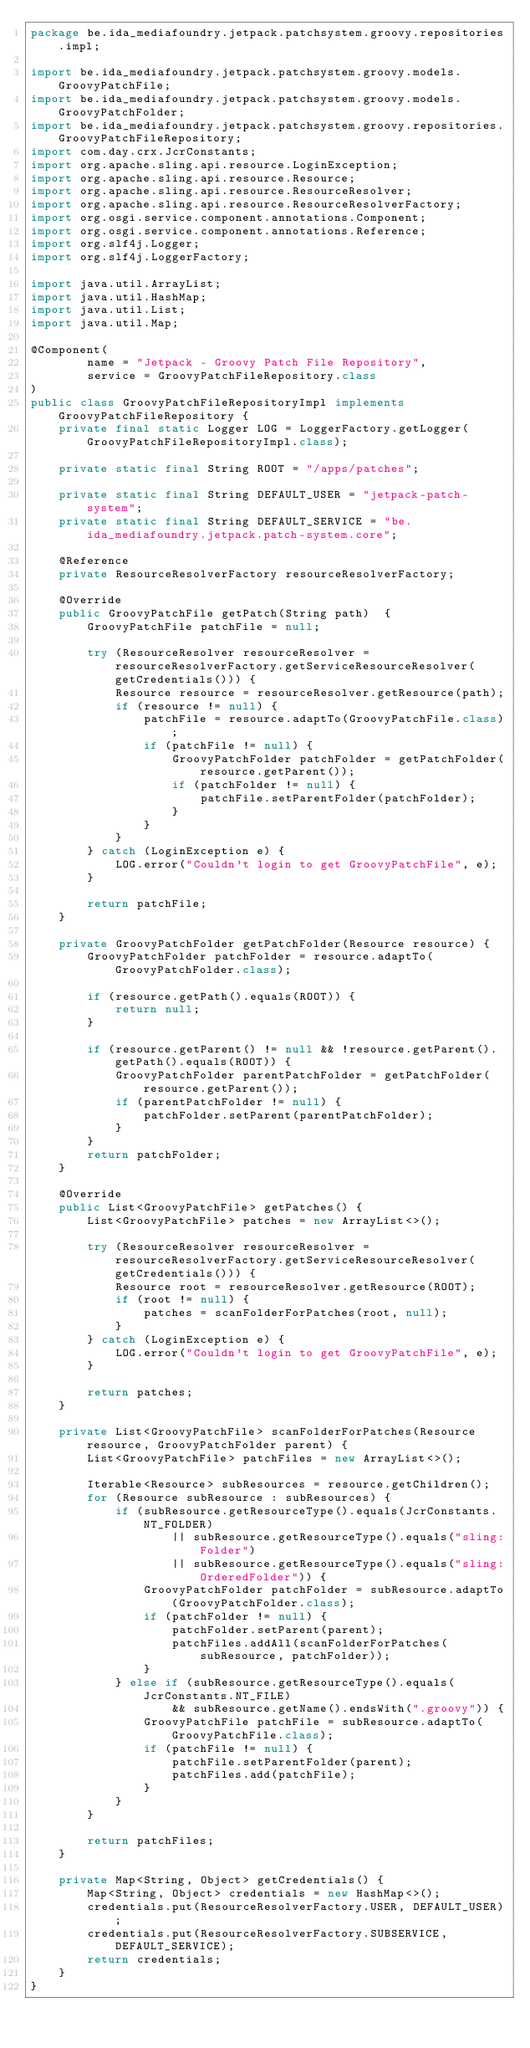Convert code to text. <code><loc_0><loc_0><loc_500><loc_500><_Java_>package be.ida_mediafoundry.jetpack.patchsystem.groovy.repositories.impl;

import be.ida_mediafoundry.jetpack.patchsystem.groovy.models.GroovyPatchFile;
import be.ida_mediafoundry.jetpack.patchsystem.groovy.models.GroovyPatchFolder;
import be.ida_mediafoundry.jetpack.patchsystem.groovy.repositories.GroovyPatchFileRepository;
import com.day.crx.JcrConstants;
import org.apache.sling.api.resource.LoginException;
import org.apache.sling.api.resource.Resource;
import org.apache.sling.api.resource.ResourceResolver;
import org.apache.sling.api.resource.ResourceResolverFactory;
import org.osgi.service.component.annotations.Component;
import org.osgi.service.component.annotations.Reference;
import org.slf4j.Logger;
import org.slf4j.LoggerFactory;

import java.util.ArrayList;
import java.util.HashMap;
import java.util.List;
import java.util.Map;

@Component(
        name = "Jetpack - Groovy Patch File Repository",
        service = GroovyPatchFileRepository.class
)
public class GroovyPatchFileRepositoryImpl implements GroovyPatchFileRepository {
    private final static Logger LOG = LoggerFactory.getLogger(GroovyPatchFileRepositoryImpl.class);

    private static final String ROOT = "/apps/patches";

    private static final String DEFAULT_USER = "jetpack-patch-system";
    private static final String DEFAULT_SERVICE = "be.ida_mediafoundry.jetpack.patch-system.core";

    @Reference
    private ResourceResolverFactory resourceResolverFactory;

    @Override
    public GroovyPatchFile getPatch(String path)  {
        GroovyPatchFile patchFile = null;

        try (ResourceResolver resourceResolver = resourceResolverFactory.getServiceResourceResolver(getCredentials())) {
            Resource resource = resourceResolver.getResource(path);
            if (resource != null) {
                patchFile = resource.adaptTo(GroovyPatchFile.class);
                if (patchFile != null) {
                    GroovyPatchFolder patchFolder = getPatchFolder(resource.getParent());
                    if (patchFolder != null) {
                        patchFile.setParentFolder(patchFolder);
                    }
                }
            }
        } catch (LoginException e) {
            LOG.error("Couldn't login to get GroovyPatchFile", e);
        }

        return patchFile;
    }

    private GroovyPatchFolder getPatchFolder(Resource resource) {
        GroovyPatchFolder patchFolder = resource.adaptTo(GroovyPatchFolder.class);

        if (resource.getPath().equals(ROOT)) {
            return null;
        }

        if (resource.getParent() != null && !resource.getParent().getPath().equals(ROOT)) {
            GroovyPatchFolder parentPatchFolder = getPatchFolder(resource.getParent());
            if (parentPatchFolder != null) {
                patchFolder.setParent(parentPatchFolder);
            }
        }
        return patchFolder;
    }

    @Override
    public List<GroovyPatchFile> getPatches() {
        List<GroovyPatchFile> patches = new ArrayList<>();

        try (ResourceResolver resourceResolver = resourceResolverFactory.getServiceResourceResolver(getCredentials())) {
            Resource root = resourceResolver.getResource(ROOT);
            if (root != null) {
                patches = scanFolderForPatches(root, null);
            }
        } catch (LoginException e) {
            LOG.error("Couldn't login to get GroovyPatchFile", e);
        }

        return patches;
    }

    private List<GroovyPatchFile> scanFolderForPatches(Resource resource, GroovyPatchFolder parent) {
        List<GroovyPatchFile> patchFiles = new ArrayList<>();

        Iterable<Resource> subResources = resource.getChildren();
        for (Resource subResource : subResources) {
            if (subResource.getResourceType().equals(JcrConstants.NT_FOLDER)
                    || subResource.getResourceType().equals("sling:Folder")
                    || subResource.getResourceType().equals("sling:OrderedFolder")) {
                GroovyPatchFolder patchFolder = subResource.adaptTo(GroovyPatchFolder.class);
                if (patchFolder != null) {
                    patchFolder.setParent(parent);
                    patchFiles.addAll(scanFolderForPatches(subResource, patchFolder));
                }
            } else if (subResource.getResourceType().equals(JcrConstants.NT_FILE)
                    && subResource.getName().endsWith(".groovy")) {
                GroovyPatchFile patchFile = subResource.adaptTo(GroovyPatchFile.class);
                if (patchFile != null) {
                    patchFile.setParentFolder(parent);
                    patchFiles.add(patchFile);
                }
            }
        }

        return patchFiles;
    }

    private Map<String, Object> getCredentials() {
        Map<String, Object> credentials = new HashMap<>();
        credentials.put(ResourceResolverFactory.USER, DEFAULT_USER);
        credentials.put(ResourceResolverFactory.SUBSERVICE, DEFAULT_SERVICE);
        return credentials;
    }
}
</code> 